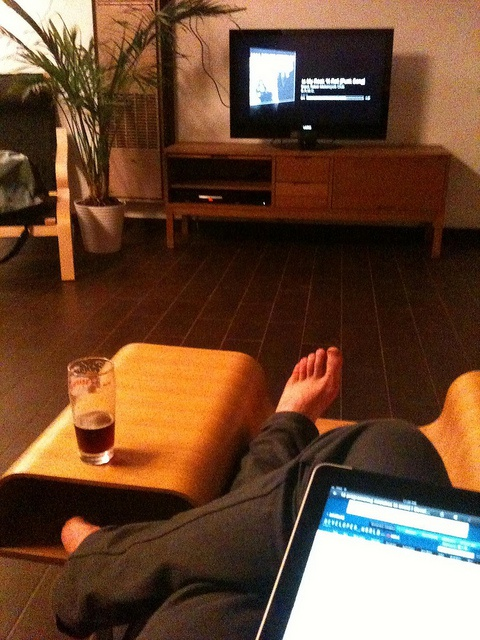Describe the objects in this image and their specific colors. I can see people in white, black, maroon, and salmon tones, tv in white, black, and lightblue tones, potted plant in white, maroon, black, and beige tones, tv in white, black, maroon, and lightblue tones, and couch in white, black, maroon, and orange tones in this image. 